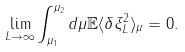Convert formula to latex. <formula><loc_0><loc_0><loc_500><loc_500>\lim _ { L \to \infty } \int _ { \mu _ { 1 } } ^ { \mu _ { 2 } } d \mu { \mathbb { E } } \langle \delta \xi _ { L } ^ { 2 } \rangle _ { \mu } = 0 .</formula> 